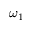Convert formula to latex. <formula><loc_0><loc_0><loc_500><loc_500>\omega _ { 1 }</formula> 